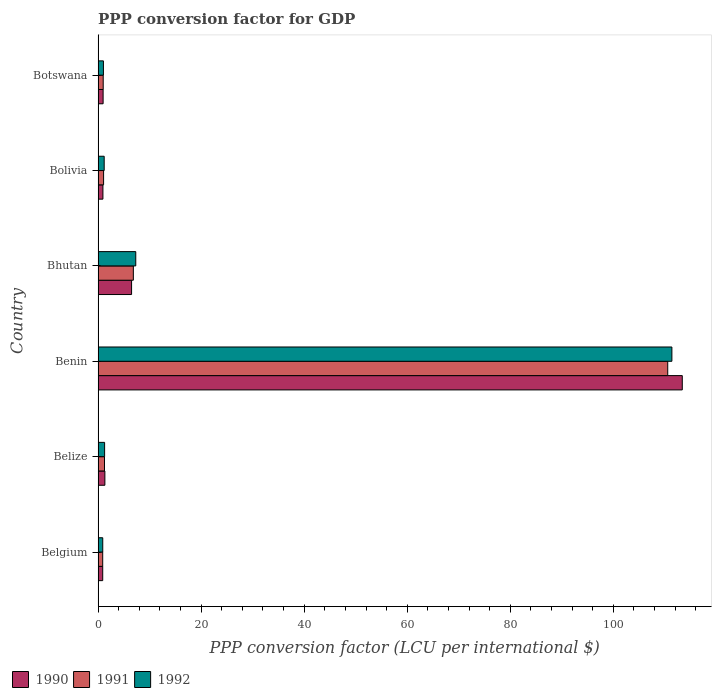How many bars are there on the 1st tick from the top?
Give a very brief answer. 3. How many bars are there on the 6th tick from the bottom?
Ensure brevity in your answer.  3. What is the label of the 5th group of bars from the top?
Your answer should be very brief. Belize. What is the PPP conversion factor for GDP in 1990 in Belgium?
Keep it short and to the point. 0.9. Across all countries, what is the maximum PPP conversion factor for GDP in 1990?
Offer a terse response. 113.38. Across all countries, what is the minimum PPP conversion factor for GDP in 1992?
Ensure brevity in your answer.  0.91. In which country was the PPP conversion factor for GDP in 1991 maximum?
Provide a short and direct response. Benin. In which country was the PPP conversion factor for GDP in 1990 minimum?
Ensure brevity in your answer.  Belgium. What is the total PPP conversion factor for GDP in 1992 in the graph?
Offer a very short reply. 123.07. What is the difference between the PPP conversion factor for GDP in 1992 in Bolivia and that in Botswana?
Make the answer very short. 0.15. What is the difference between the PPP conversion factor for GDP in 1992 in Bolivia and the PPP conversion factor for GDP in 1991 in Benin?
Provide a short and direct response. -109.37. What is the average PPP conversion factor for GDP in 1990 per country?
Offer a very short reply. 20.67. What is the difference between the PPP conversion factor for GDP in 1991 and PPP conversion factor for GDP in 1992 in Bolivia?
Ensure brevity in your answer.  -0.11. In how many countries, is the PPP conversion factor for GDP in 1992 greater than 44 LCU?
Provide a succinct answer. 1. What is the ratio of the PPP conversion factor for GDP in 1991 in Belgium to that in Belize?
Ensure brevity in your answer.  0.72. Is the PPP conversion factor for GDP in 1992 in Benin less than that in Bolivia?
Give a very brief answer. No. What is the difference between the highest and the second highest PPP conversion factor for GDP in 1991?
Your answer should be compact. 103.72. What is the difference between the highest and the lowest PPP conversion factor for GDP in 1990?
Keep it short and to the point. 112.48. What does the 1st bar from the bottom in Belgium represents?
Your response must be concise. 1990. Is it the case that in every country, the sum of the PPP conversion factor for GDP in 1991 and PPP conversion factor for GDP in 1990 is greater than the PPP conversion factor for GDP in 1992?
Offer a terse response. Yes. How many bars are there?
Your response must be concise. 18. Does the graph contain any zero values?
Provide a succinct answer. No. Where does the legend appear in the graph?
Your answer should be compact. Bottom left. How many legend labels are there?
Your answer should be compact. 3. How are the legend labels stacked?
Offer a very short reply. Horizontal. What is the title of the graph?
Provide a short and direct response. PPP conversion factor for GDP. Does "1982" appear as one of the legend labels in the graph?
Give a very brief answer. No. What is the label or title of the X-axis?
Keep it short and to the point. PPP conversion factor (LCU per international $). What is the label or title of the Y-axis?
Your answer should be compact. Country. What is the PPP conversion factor (LCU per international $) in 1990 in Belgium?
Your answer should be very brief. 0.9. What is the PPP conversion factor (LCU per international $) of 1991 in Belgium?
Give a very brief answer. 0.9. What is the PPP conversion factor (LCU per international $) in 1992 in Belgium?
Keep it short and to the point. 0.91. What is the PPP conversion factor (LCU per international $) in 1990 in Belize?
Your answer should be compact. 1.32. What is the PPP conversion factor (LCU per international $) in 1991 in Belize?
Ensure brevity in your answer.  1.24. What is the PPP conversion factor (LCU per international $) of 1992 in Belize?
Ensure brevity in your answer.  1.27. What is the PPP conversion factor (LCU per international $) in 1990 in Benin?
Provide a short and direct response. 113.38. What is the PPP conversion factor (LCU per international $) of 1991 in Benin?
Make the answer very short. 110.56. What is the PPP conversion factor (LCU per international $) of 1992 in Benin?
Keep it short and to the point. 111.36. What is the PPP conversion factor (LCU per international $) of 1990 in Bhutan?
Ensure brevity in your answer.  6.5. What is the PPP conversion factor (LCU per international $) of 1991 in Bhutan?
Offer a terse response. 6.84. What is the PPP conversion factor (LCU per international $) in 1992 in Bhutan?
Your answer should be compact. 7.31. What is the PPP conversion factor (LCU per international $) in 1990 in Bolivia?
Provide a short and direct response. 0.94. What is the PPP conversion factor (LCU per international $) in 1991 in Bolivia?
Make the answer very short. 1.07. What is the PPP conversion factor (LCU per international $) in 1992 in Bolivia?
Offer a very short reply. 1.18. What is the PPP conversion factor (LCU per international $) of 1990 in Botswana?
Your response must be concise. 0.98. What is the PPP conversion factor (LCU per international $) in 1991 in Botswana?
Ensure brevity in your answer.  0.99. What is the PPP conversion factor (LCU per international $) in 1992 in Botswana?
Your answer should be very brief. 1.04. Across all countries, what is the maximum PPP conversion factor (LCU per international $) in 1990?
Provide a short and direct response. 113.38. Across all countries, what is the maximum PPP conversion factor (LCU per international $) of 1991?
Your answer should be compact. 110.56. Across all countries, what is the maximum PPP conversion factor (LCU per international $) of 1992?
Your response must be concise. 111.36. Across all countries, what is the minimum PPP conversion factor (LCU per international $) in 1990?
Your answer should be compact. 0.9. Across all countries, what is the minimum PPP conversion factor (LCU per international $) in 1991?
Your answer should be very brief. 0.9. Across all countries, what is the minimum PPP conversion factor (LCU per international $) in 1992?
Keep it short and to the point. 0.91. What is the total PPP conversion factor (LCU per international $) of 1990 in the graph?
Your answer should be very brief. 124.02. What is the total PPP conversion factor (LCU per international $) in 1991 in the graph?
Your response must be concise. 121.6. What is the total PPP conversion factor (LCU per international $) in 1992 in the graph?
Keep it short and to the point. 123.07. What is the difference between the PPP conversion factor (LCU per international $) of 1990 in Belgium and that in Belize?
Ensure brevity in your answer.  -0.42. What is the difference between the PPP conversion factor (LCU per international $) of 1991 in Belgium and that in Belize?
Provide a short and direct response. -0.35. What is the difference between the PPP conversion factor (LCU per international $) in 1992 in Belgium and that in Belize?
Ensure brevity in your answer.  -0.36. What is the difference between the PPP conversion factor (LCU per international $) in 1990 in Belgium and that in Benin?
Provide a succinct answer. -112.48. What is the difference between the PPP conversion factor (LCU per international $) in 1991 in Belgium and that in Benin?
Your answer should be very brief. -109.66. What is the difference between the PPP conversion factor (LCU per international $) of 1992 in Belgium and that in Benin?
Offer a very short reply. -110.46. What is the difference between the PPP conversion factor (LCU per international $) in 1990 in Belgium and that in Bhutan?
Give a very brief answer. -5.6. What is the difference between the PPP conversion factor (LCU per international $) of 1991 in Belgium and that in Bhutan?
Ensure brevity in your answer.  -5.95. What is the difference between the PPP conversion factor (LCU per international $) in 1992 in Belgium and that in Bhutan?
Offer a very short reply. -6.41. What is the difference between the PPP conversion factor (LCU per international $) in 1990 in Belgium and that in Bolivia?
Your response must be concise. -0.04. What is the difference between the PPP conversion factor (LCU per international $) in 1991 in Belgium and that in Bolivia?
Keep it short and to the point. -0.18. What is the difference between the PPP conversion factor (LCU per international $) of 1992 in Belgium and that in Bolivia?
Offer a very short reply. -0.28. What is the difference between the PPP conversion factor (LCU per international $) in 1990 in Belgium and that in Botswana?
Your answer should be very brief. -0.08. What is the difference between the PPP conversion factor (LCU per international $) in 1991 in Belgium and that in Botswana?
Provide a succinct answer. -0.1. What is the difference between the PPP conversion factor (LCU per international $) of 1992 in Belgium and that in Botswana?
Give a very brief answer. -0.13. What is the difference between the PPP conversion factor (LCU per international $) of 1990 in Belize and that in Benin?
Give a very brief answer. -112.06. What is the difference between the PPP conversion factor (LCU per international $) in 1991 in Belize and that in Benin?
Give a very brief answer. -109.31. What is the difference between the PPP conversion factor (LCU per international $) of 1992 in Belize and that in Benin?
Keep it short and to the point. -110.1. What is the difference between the PPP conversion factor (LCU per international $) in 1990 in Belize and that in Bhutan?
Your response must be concise. -5.18. What is the difference between the PPP conversion factor (LCU per international $) in 1991 in Belize and that in Bhutan?
Offer a terse response. -5.6. What is the difference between the PPP conversion factor (LCU per international $) of 1992 in Belize and that in Bhutan?
Offer a very short reply. -6.05. What is the difference between the PPP conversion factor (LCU per international $) in 1990 in Belize and that in Bolivia?
Ensure brevity in your answer.  0.38. What is the difference between the PPP conversion factor (LCU per international $) of 1991 in Belize and that in Bolivia?
Make the answer very short. 0.17. What is the difference between the PPP conversion factor (LCU per international $) of 1992 in Belize and that in Bolivia?
Provide a short and direct response. 0.08. What is the difference between the PPP conversion factor (LCU per international $) in 1990 in Belize and that in Botswana?
Your answer should be very brief. 0.34. What is the difference between the PPP conversion factor (LCU per international $) in 1991 in Belize and that in Botswana?
Your response must be concise. 0.25. What is the difference between the PPP conversion factor (LCU per international $) in 1992 in Belize and that in Botswana?
Ensure brevity in your answer.  0.23. What is the difference between the PPP conversion factor (LCU per international $) in 1990 in Benin and that in Bhutan?
Your answer should be very brief. 106.88. What is the difference between the PPP conversion factor (LCU per international $) in 1991 in Benin and that in Bhutan?
Keep it short and to the point. 103.72. What is the difference between the PPP conversion factor (LCU per international $) in 1992 in Benin and that in Bhutan?
Make the answer very short. 104.05. What is the difference between the PPP conversion factor (LCU per international $) of 1990 in Benin and that in Bolivia?
Ensure brevity in your answer.  112.44. What is the difference between the PPP conversion factor (LCU per international $) in 1991 in Benin and that in Bolivia?
Provide a short and direct response. 109.49. What is the difference between the PPP conversion factor (LCU per international $) of 1992 in Benin and that in Bolivia?
Your answer should be very brief. 110.18. What is the difference between the PPP conversion factor (LCU per international $) in 1990 in Benin and that in Botswana?
Offer a terse response. 112.4. What is the difference between the PPP conversion factor (LCU per international $) of 1991 in Benin and that in Botswana?
Offer a terse response. 109.56. What is the difference between the PPP conversion factor (LCU per international $) in 1992 in Benin and that in Botswana?
Provide a succinct answer. 110.33. What is the difference between the PPP conversion factor (LCU per international $) in 1990 in Bhutan and that in Bolivia?
Provide a succinct answer. 5.56. What is the difference between the PPP conversion factor (LCU per international $) of 1991 in Bhutan and that in Bolivia?
Provide a succinct answer. 5.77. What is the difference between the PPP conversion factor (LCU per international $) in 1992 in Bhutan and that in Bolivia?
Provide a short and direct response. 6.13. What is the difference between the PPP conversion factor (LCU per international $) of 1990 in Bhutan and that in Botswana?
Offer a very short reply. 5.52. What is the difference between the PPP conversion factor (LCU per international $) of 1991 in Bhutan and that in Botswana?
Offer a terse response. 5.85. What is the difference between the PPP conversion factor (LCU per international $) of 1992 in Bhutan and that in Botswana?
Ensure brevity in your answer.  6.28. What is the difference between the PPP conversion factor (LCU per international $) of 1990 in Bolivia and that in Botswana?
Make the answer very short. -0.04. What is the difference between the PPP conversion factor (LCU per international $) of 1991 in Bolivia and that in Botswana?
Ensure brevity in your answer.  0.08. What is the difference between the PPP conversion factor (LCU per international $) in 1992 in Bolivia and that in Botswana?
Give a very brief answer. 0.15. What is the difference between the PPP conversion factor (LCU per international $) of 1990 in Belgium and the PPP conversion factor (LCU per international $) of 1991 in Belize?
Your answer should be compact. -0.34. What is the difference between the PPP conversion factor (LCU per international $) of 1990 in Belgium and the PPP conversion factor (LCU per international $) of 1992 in Belize?
Provide a succinct answer. -0.37. What is the difference between the PPP conversion factor (LCU per international $) in 1991 in Belgium and the PPP conversion factor (LCU per international $) in 1992 in Belize?
Your answer should be compact. -0.37. What is the difference between the PPP conversion factor (LCU per international $) of 1990 in Belgium and the PPP conversion factor (LCU per international $) of 1991 in Benin?
Make the answer very short. -109.66. What is the difference between the PPP conversion factor (LCU per international $) of 1990 in Belgium and the PPP conversion factor (LCU per international $) of 1992 in Benin?
Ensure brevity in your answer.  -110.46. What is the difference between the PPP conversion factor (LCU per international $) in 1991 in Belgium and the PPP conversion factor (LCU per international $) in 1992 in Benin?
Your answer should be very brief. -110.47. What is the difference between the PPP conversion factor (LCU per international $) of 1990 in Belgium and the PPP conversion factor (LCU per international $) of 1991 in Bhutan?
Provide a short and direct response. -5.94. What is the difference between the PPP conversion factor (LCU per international $) of 1990 in Belgium and the PPP conversion factor (LCU per international $) of 1992 in Bhutan?
Provide a succinct answer. -6.41. What is the difference between the PPP conversion factor (LCU per international $) in 1991 in Belgium and the PPP conversion factor (LCU per international $) in 1992 in Bhutan?
Your answer should be compact. -6.42. What is the difference between the PPP conversion factor (LCU per international $) of 1990 in Belgium and the PPP conversion factor (LCU per international $) of 1991 in Bolivia?
Your answer should be compact. -0.17. What is the difference between the PPP conversion factor (LCU per international $) of 1990 in Belgium and the PPP conversion factor (LCU per international $) of 1992 in Bolivia?
Provide a short and direct response. -0.29. What is the difference between the PPP conversion factor (LCU per international $) in 1991 in Belgium and the PPP conversion factor (LCU per international $) in 1992 in Bolivia?
Make the answer very short. -0.29. What is the difference between the PPP conversion factor (LCU per international $) in 1990 in Belgium and the PPP conversion factor (LCU per international $) in 1991 in Botswana?
Make the answer very short. -0.09. What is the difference between the PPP conversion factor (LCU per international $) of 1990 in Belgium and the PPP conversion factor (LCU per international $) of 1992 in Botswana?
Make the answer very short. -0.14. What is the difference between the PPP conversion factor (LCU per international $) in 1991 in Belgium and the PPP conversion factor (LCU per international $) in 1992 in Botswana?
Your response must be concise. -0.14. What is the difference between the PPP conversion factor (LCU per international $) of 1990 in Belize and the PPP conversion factor (LCU per international $) of 1991 in Benin?
Your response must be concise. -109.24. What is the difference between the PPP conversion factor (LCU per international $) of 1990 in Belize and the PPP conversion factor (LCU per international $) of 1992 in Benin?
Ensure brevity in your answer.  -110.04. What is the difference between the PPP conversion factor (LCU per international $) of 1991 in Belize and the PPP conversion factor (LCU per international $) of 1992 in Benin?
Give a very brief answer. -110.12. What is the difference between the PPP conversion factor (LCU per international $) of 1990 in Belize and the PPP conversion factor (LCU per international $) of 1991 in Bhutan?
Your response must be concise. -5.52. What is the difference between the PPP conversion factor (LCU per international $) in 1990 in Belize and the PPP conversion factor (LCU per international $) in 1992 in Bhutan?
Provide a short and direct response. -5.99. What is the difference between the PPP conversion factor (LCU per international $) of 1991 in Belize and the PPP conversion factor (LCU per international $) of 1992 in Bhutan?
Provide a short and direct response. -6.07. What is the difference between the PPP conversion factor (LCU per international $) in 1990 in Belize and the PPP conversion factor (LCU per international $) in 1991 in Bolivia?
Offer a very short reply. 0.25. What is the difference between the PPP conversion factor (LCU per international $) of 1990 in Belize and the PPP conversion factor (LCU per international $) of 1992 in Bolivia?
Your answer should be compact. 0.13. What is the difference between the PPP conversion factor (LCU per international $) in 1991 in Belize and the PPP conversion factor (LCU per international $) in 1992 in Bolivia?
Ensure brevity in your answer.  0.06. What is the difference between the PPP conversion factor (LCU per international $) in 1990 in Belize and the PPP conversion factor (LCU per international $) in 1991 in Botswana?
Ensure brevity in your answer.  0.33. What is the difference between the PPP conversion factor (LCU per international $) in 1990 in Belize and the PPP conversion factor (LCU per international $) in 1992 in Botswana?
Keep it short and to the point. 0.28. What is the difference between the PPP conversion factor (LCU per international $) of 1991 in Belize and the PPP conversion factor (LCU per international $) of 1992 in Botswana?
Your response must be concise. 0.21. What is the difference between the PPP conversion factor (LCU per international $) in 1990 in Benin and the PPP conversion factor (LCU per international $) in 1991 in Bhutan?
Offer a very short reply. 106.54. What is the difference between the PPP conversion factor (LCU per international $) of 1990 in Benin and the PPP conversion factor (LCU per international $) of 1992 in Bhutan?
Provide a succinct answer. 106.07. What is the difference between the PPP conversion factor (LCU per international $) of 1991 in Benin and the PPP conversion factor (LCU per international $) of 1992 in Bhutan?
Offer a terse response. 103.25. What is the difference between the PPP conversion factor (LCU per international $) of 1990 in Benin and the PPP conversion factor (LCU per international $) of 1991 in Bolivia?
Offer a terse response. 112.31. What is the difference between the PPP conversion factor (LCU per international $) of 1990 in Benin and the PPP conversion factor (LCU per international $) of 1992 in Bolivia?
Offer a very short reply. 112.2. What is the difference between the PPP conversion factor (LCU per international $) of 1991 in Benin and the PPP conversion factor (LCU per international $) of 1992 in Bolivia?
Ensure brevity in your answer.  109.37. What is the difference between the PPP conversion factor (LCU per international $) of 1990 in Benin and the PPP conversion factor (LCU per international $) of 1991 in Botswana?
Provide a short and direct response. 112.39. What is the difference between the PPP conversion factor (LCU per international $) in 1990 in Benin and the PPP conversion factor (LCU per international $) in 1992 in Botswana?
Ensure brevity in your answer.  112.34. What is the difference between the PPP conversion factor (LCU per international $) in 1991 in Benin and the PPP conversion factor (LCU per international $) in 1992 in Botswana?
Offer a very short reply. 109.52. What is the difference between the PPP conversion factor (LCU per international $) of 1990 in Bhutan and the PPP conversion factor (LCU per international $) of 1991 in Bolivia?
Give a very brief answer. 5.43. What is the difference between the PPP conversion factor (LCU per international $) of 1990 in Bhutan and the PPP conversion factor (LCU per international $) of 1992 in Bolivia?
Your response must be concise. 5.32. What is the difference between the PPP conversion factor (LCU per international $) of 1991 in Bhutan and the PPP conversion factor (LCU per international $) of 1992 in Bolivia?
Ensure brevity in your answer.  5.66. What is the difference between the PPP conversion factor (LCU per international $) in 1990 in Bhutan and the PPP conversion factor (LCU per international $) in 1991 in Botswana?
Your answer should be very brief. 5.51. What is the difference between the PPP conversion factor (LCU per international $) of 1990 in Bhutan and the PPP conversion factor (LCU per international $) of 1992 in Botswana?
Your answer should be compact. 5.46. What is the difference between the PPP conversion factor (LCU per international $) of 1991 in Bhutan and the PPP conversion factor (LCU per international $) of 1992 in Botswana?
Offer a terse response. 5.81. What is the difference between the PPP conversion factor (LCU per international $) of 1990 in Bolivia and the PPP conversion factor (LCU per international $) of 1991 in Botswana?
Provide a short and direct response. -0.05. What is the difference between the PPP conversion factor (LCU per international $) in 1990 in Bolivia and the PPP conversion factor (LCU per international $) in 1992 in Botswana?
Your response must be concise. -0.1. What is the difference between the PPP conversion factor (LCU per international $) in 1991 in Bolivia and the PPP conversion factor (LCU per international $) in 1992 in Botswana?
Offer a very short reply. 0.03. What is the average PPP conversion factor (LCU per international $) of 1990 per country?
Your answer should be compact. 20.67. What is the average PPP conversion factor (LCU per international $) in 1991 per country?
Your answer should be compact. 20.27. What is the average PPP conversion factor (LCU per international $) in 1992 per country?
Offer a terse response. 20.51. What is the difference between the PPP conversion factor (LCU per international $) in 1990 and PPP conversion factor (LCU per international $) in 1991 in Belgium?
Provide a succinct answer. 0. What is the difference between the PPP conversion factor (LCU per international $) of 1990 and PPP conversion factor (LCU per international $) of 1992 in Belgium?
Make the answer very short. -0.01. What is the difference between the PPP conversion factor (LCU per international $) of 1991 and PPP conversion factor (LCU per international $) of 1992 in Belgium?
Your answer should be compact. -0.01. What is the difference between the PPP conversion factor (LCU per international $) in 1990 and PPP conversion factor (LCU per international $) in 1991 in Belize?
Your answer should be compact. 0.08. What is the difference between the PPP conversion factor (LCU per international $) of 1990 and PPP conversion factor (LCU per international $) of 1992 in Belize?
Ensure brevity in your answer.  0.05. What is the difference between the PPP conversion factor (LCU per international $) of 1991 and PPP conversion factor (LCU per international $) of 1992 in Belize?
Keep it short and to the point. -0.02. What is the difference between the PPP conversion factor (LCU per international $) of 1990 and PPP conversion factor (LCU per international $) of 1991 in Benin?
Your answer should be very brief. 2.82. What is the difference between the PPP conversion factor (LCU per international $) in 1990 and PPP conversion factor (LCU per international $) in 1992 in Benin?
Your response must be concise. 2.02. What is the difference between the PPP conversion factor (LCU per international $) in 1991 and PPP conversion factor (LCU per international $) in 1992 in Benin?
Provide a succinct answer. -0.81. What is the difference between the PPP conversion factor (LCU per international $) of 1990 and PPP conversion factor (LCU per international $) of 1991 in Bhutan?
Your response must be concise. -0.34. What is the difference between the PPP conversion factor (LCU per international $) of 1990 and PPP conversion factor (LCU per international $) of 1992 in Bhutan?
Your response must be concise. -0.81. What is the difference between the PPP conversion factor (LCU per international $) of 1991 and PPP conversion factor (LCU per international $) of 1992 in Bhutan?
Provide a short and direct response. -0.47. What is the difference between the PPP conversion factor (LCU per international $) of 1990 and PPP conversion factor (LCU per international $) of 1991 in Bolivia?
Provide a short and direct response. -0.13. What is the difference between the PPP conversion factor (LCU per international $) in 1990 and PPP conversion factor (LCU per international $) in 1992 in Bolivia?
Your response must be concise. -0.24. What is the difference between the PPP conversion factor (LCU per international $) of 1991 and PPP conversion factor (LCU per international $) of 1992 in Bolivia?
Your response must be concise. -0.11. What is the difference between the PPP conversion factor (LCU per international $) in 1990 and PPP conversion factor (LCU per international $) in 1991 in Botswana?
Provide a short and direct response. -0.02. What is the difference between the PPP conversion factor (LCU per international $) in 1990 and PPP conversion factor (LCU per international $) in 1992 in Botswana?
Make the answer very short. -0.06. What is the difference between the PPP conversion factor (LCU per international $) in 1991 and PPP conversion factor (LCU per international $) in 1992 in Botswana?
Offer a very short reply. -0.04. What is the ratio of the PPP conversion factor (LCU per international $) of 1990 in Belgium to that in Belize?
Make the answer very short. 0.68. What is the ratio of the PPP conversion factor (LCU per international $) of 1991 in Belgium to that in Belize?
Give a very brief answer. 0.72. What is the ratio of the PPP conversion factor (LCU per international $) in 1992 in Belgium to that in Belize?
Give a very brief answer. 0.72. What is the ratio of the PPP conversion factor (LCU per international $) of 1990 in Belgium to that in Benin?
Your answer should be compact. 0.01. What is the ratio of the PPP conversion factor (LCU per international $) in 1991 in Belgium to that in Benin?
Keep it short and to the point. 0.01. What is the ratio of the PPP conversion factor (LCU per international $) of 1992 in Belgium to that in Benin?
Give a very brief answer. 0.01. What is the ratio of the PPP conversion factor (LCU per international $) in 1990 in Belgium to that in Bhutan?
Provide a short and direct response. 0.14. What is the ratio of the PPP conversion factor (LCU per international $) in 1991 in Belgium to that in Bhutan?
Keep it short and to the point. 0.13. What is the ratio of the PPP conversion factor (LCU per international $) in 1992 in Belgium to that in Bhutan?
Make the answer very short. 0.12. What is the ratio of the PPP conversion factor (LCU per international $) in 1990 in Belgium to that in Bolivia?
Your answer should be compact. 0.96. What is the ratio of the PPP conversion factor (LCU per international $) of 1991 in Belgium to that in Bolivia?
Your answer should be compact. 0.84. What is the ratio of the PPP conversion factor (LCU per international $) in 1992 in Belgium to that in Bolivia?
Provide a short and direct response. 0.76. What is the ratio of the PPP conversion factor (LCU per international $) in 1990 in Belgium to that in Botswana?
Your answer should be very brief. 0.92. What is the ratio of the PPP conversion factor (LCU per international $) of 1991 in Belgium to that in Botswana?
Provide a succinct answer. 0.9. What is the ratio of the PPP conversion factor (LCU per international $) of 1992 in Belgium to that in Botswana?
Your answer should be very brief. 0.87. What is the ratio of the PPP conversion factor (LCU per international $) of 1990 in Belize to that in Benin?
Provide a short and direct response. 0.01. What is the ratio of the PPP conversion factor (LCU per international $) of 1991 in Belize to that in Benin?
Ensure brevity in your answer.  0.01. What is the ratio of the PPP conversion factor (LCU per international $) of 1992 in Belize to that in Benin?
Make the answer very short. 0.01. What is the ratio of the PPP conversion factor (LCU per international $) in 1990 in Belize to that in Bhutan?
Keep it short and to the point. 0.2. What is the ratio of the PPP conversion factor (LCU per international $) of 1991 in Belize to that in Bhutan?
Make the answer very short. 0.18. What is the ratio of the PPP conversion factor (LCU per international $) in 1992 in Belize to that in Bhutan?
Ensure brevity in your answer.  0.17. What is the ratio of the PPP conversion factor (LCU per international $) of 1990 in Belize to that in Bolivia?
Keep it short and to the point. 1.4. What is the ratio of the PPP conversion factor (LCU per international $) in 1991 in Belize to that in Bolivia?
Give a very brief answer. 1.16. What is the ratio of the PPP conversion factor (LCU per international $) in 1992 in Belize to that in Bolivia?
Your answer should be very brief. 1.07. What is the ratio of the PPP conversion factor (LCU per international $) in 1990 in Belize to that in Botswana?
Offer a very short reply. 1.35. What is the ratio of the PPP conversion factor (LCU per international $) of 1991 in Belize to that in Botswana?
Make the answer very short. 1.25. What is the ratio of the PPP conversion factor (LCU per international $) in 1992 in Belize to that in Botswana?
Your answer should be compact. 1.22. What is the ratio of the PPP conversion factor (LCU per international $) in 1990 in Benin to that in Bhutan?
Offer a terse response. 17.44. What is the ratio of the PPP conversion factor (LCU per international $) in 1991 in Benin to that in Bhutan?
Provide a succinct answer. 16.16. What is the ratio of the PPP conversion factor (LCU per international $) of 1992 in Benin to that in Bhutan?
Offer a terse response. 15.23. What is the ratio of the PPP conversion factor (LCU per international $) in 1990 in Benin to that in Bolivia?
Your response must be concise. 120.61. What is the ratio of the PPP conversion factor (LCU per international $) in 1991 in Benin to that in Bolivia?
Make the answer very short. 103.26. What is the ratio of the PPP conversion factor (LCU per international $) of 1992 in Benin to that in Bolivia?
Ensure brevity in your answer.  93.98. What is the ratio of the PPP conversion factor (LCU per international $) in 1990 in Benin to that in Botswana?
Ensure brevity in your answer.  116.12. What is the ratio of the PPP conversion factor (LCU per international $) in 1991 in Benin to that in Botswana?
Ensure brevity in your answer.  111.24. What is the ratio of the PPP conversion factor (LCU per international $) in 1992 in Benin to that in Botswana?
Keep it short and to the point. 107.47. What is the ratio of the PPP conversion factor (LCU per international $) in 1990 in Bhutan to that in Bolivia?
Ensure brevity in your answer.  6.92. What is the ratio of the PPP conversion factor (LCU per international $) of 1991 in Bhutan to that in Bolivia?
Give a very brief answer. 6.39. What is the ratio of the PPP conversion factor (LCU per international $) of 1992 in Bhutan to that in Bolivia?
Provide a succinct answer. 6.17. What is the ratio of the PPP conversion factor (LCU per international $) in 1990 in Bhutan to that in Botswana?
Your answer should be very brief. 6.66. What is the ratio of the PPP conversion factor (LCU per international $) in 1991 in Bhutan to that in Botswana?
Make the answer very short. 6.89. What is the ratio of the PPP conversion factor (LCU per international $) of 1992 in Bhutan to that in Botswana?
Keep it short and to the point. 7.06. What is the ratio of the PPP conversion factor (LCU per international $) in 1990 in Bolivia to that in Botswana?
Make the answer very short. 0.96. What is the ratio of the PPP conversion factor (LCU per international $) in 1991 in Bolivia to that in Botswana?
Make the answer very short. 1.08. What is the ratio of the PPP conversion factor (LCU per international $) in 1992 in Bolivia to that in Botswana?
Give a very brief answer. 1.14. What is the difference between the highest and the second highest PPP conversion factor (LCU per international $) of 1990?
Ensure brevity in your answer.  106.88. What is the difference between the highest and the second highest PPP conversion factor (LCU per international $) of 1991?
Your answer should be very brief. 103.72. What is the difference between the highest and the second highest PPP conversion factor (LCU per international $) of 1992?
Your response must be concise. 104.05. What is the difference between the highest and the lowest PPP conversion factor (LCU per international $) in 1990?
Provide a short and direct response. 112.48. What is the difference between the highest and the lowest PPP conversion factor (LCU per international $) in 1991?
Keep it short and to the point. 109.66. What is the difference between the highest and the lowest PPP conversion factor (LCU per international $) of 1992?
Offer a terse response. 110.46. 